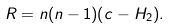Convert formula to latex. <formula><loc_0><loc_0><loc_500><loc_500>R = n ( n - 1 ) ( c - H _ { 2 } ) .</formula> 